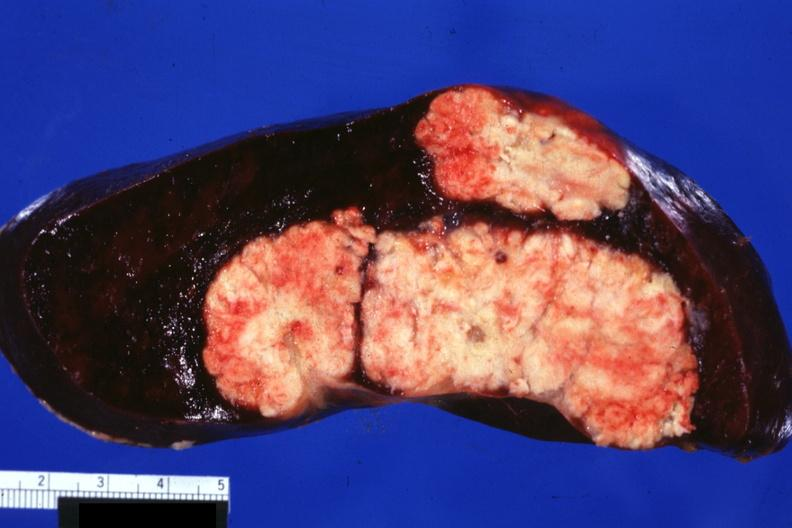what is present?
Answer the question using a single word or phrase. Spleen 